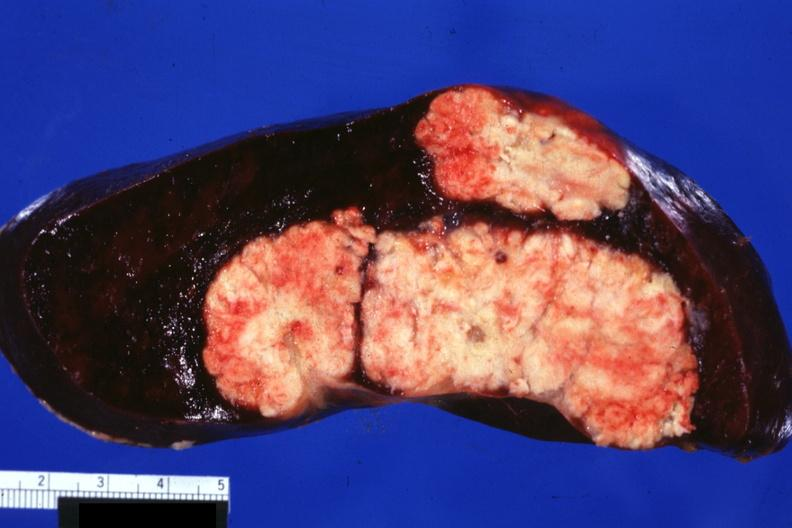what is present?
Answer the question using a single word or phrase. Spleen 